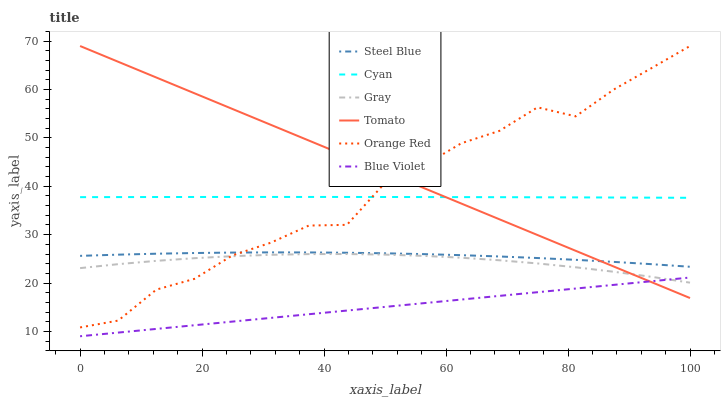Does Blue Violet have the minimum area under the curve?
Answer yes or no. Yes. Does Tomato have the maximum area under the curve?
Answer yes or no. Yes. Does Gray have the minimum area under the curve?
Answer yes or no. No. Does Gray have the maximum area under the curve?
Answer yes or no. No. Is Blue Violet the smoothest?
Answer yes or no. Yes. Is Orange Red the roughest?
Answer yes or no. Yes. Is Gray the smoothest?
Answer yes or no. No. Is Gray the roughest?
Answer yes or no. No. Does Blue Violet have the lowest value?
Answer yes or no. Yes. Does Gray have the lowest value?
Answer yes or no. No. Does Orange Red have the highest value?
Answer yes or no. Yes. Does Gray have the highest value?
Answer yes or no. No. Is Blue Violet less than Orange Red?
Answer yes or no. Yes. Is Cyan greater than Blue Violet?
Answer yes or no. Yes. Does Orange Red intersect Tomato?
Answer yes or no. Yes. Is Orange Red less than Tomato?
Answer yes or no. No. Is Orange Red greater than Tomato?
Answer yes or no. No. Does Blue Violet intersect Orange Red?
Answer yes or no. No. 